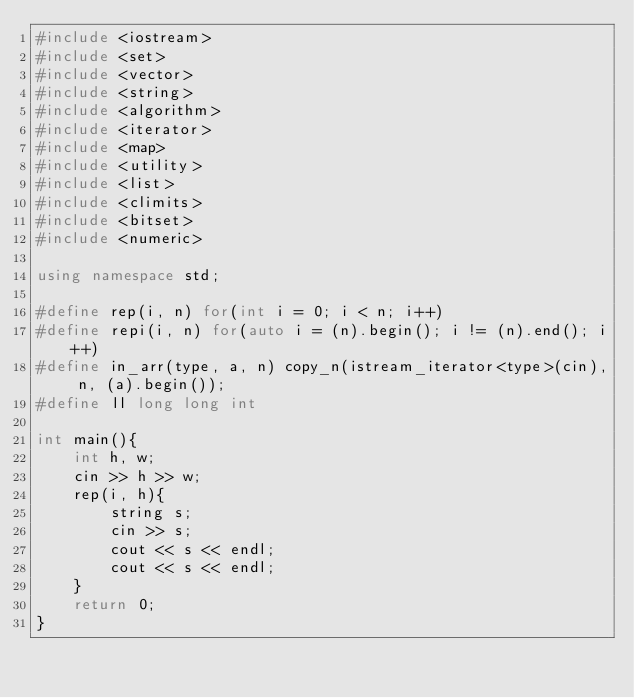Convert code to text. <code><loc_0><loc_0><loc_500><loc_500><_C++_>#include <iostream>
#include <set>
#include <vector>
#include <string>
#include <algorithm>
#include <iterator>
#include <map>
#include <utility>
#include <list>
#include <climits>
#include <bitset>
#include <numeric>

using namespace std;

#define rep(i, n) for(int i = 0; i < n; i++)
#define repi(i, n) for(auto i = (n).begin(); i != (n).end(); i++)
#define in_arr(type, a, n) copy_n(istream_iterator<type>(cin), n, (a).begin());
#define ll long long int

int main(){
    int h, w;
    cin >> h >> w;
    rep(i, h){
        string s;
        cin >> s;
        cout << s << endl;
        cout << s << endl;
    }
    return 0;
}
</code> 